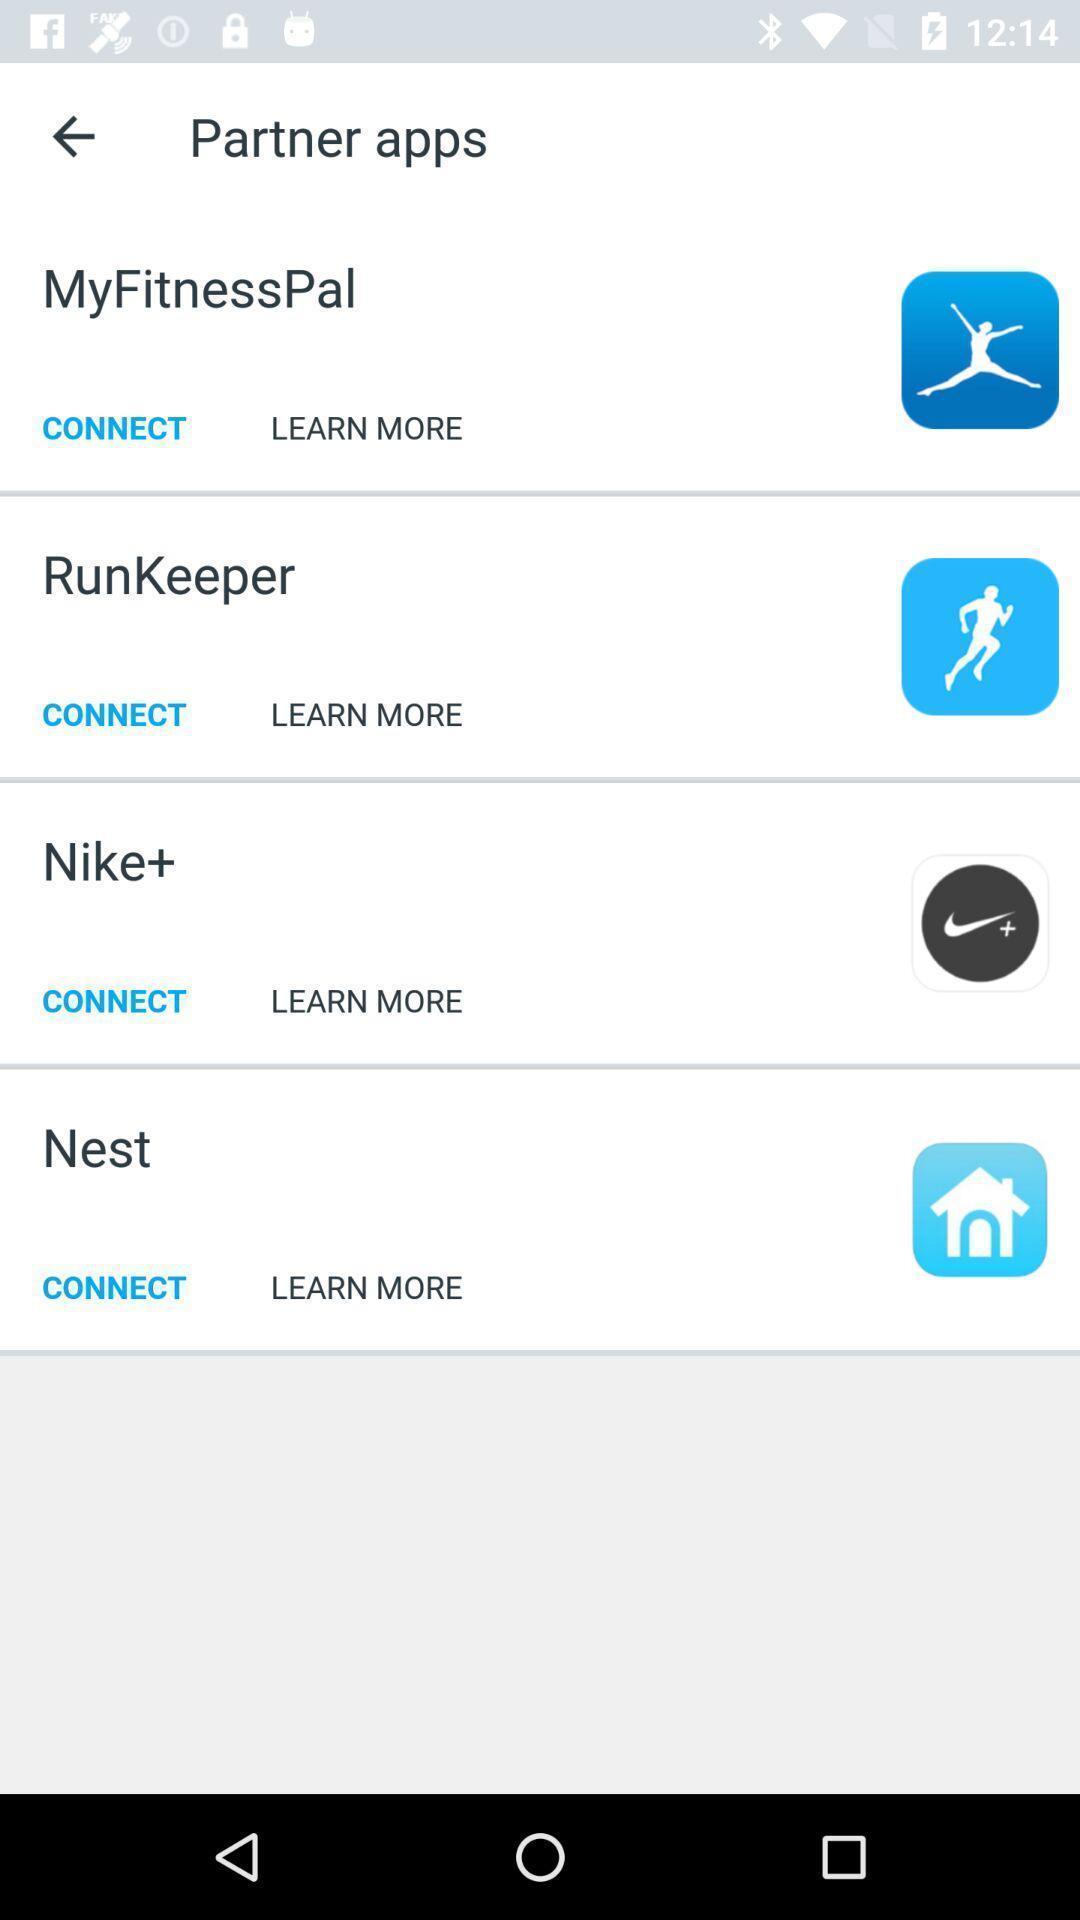Describe this image in words. Screen displaying multiple social icons in a health tracking application. 